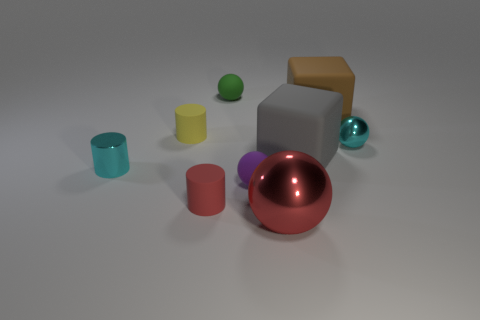Subtract 1 balls. How many balls are left? 3 Subtract all blocks. How many objects are left? 7 Add 3 rubber balls. How many rubber balls exist? 5 Subtract 0 purple cubes. How many objects are left? 9 Subtract all purple shiny balls. Subtract all purple matte things. How many objects are left? 8 Add 9 yellow cylinders. How many yellow cylinders are left? 10 